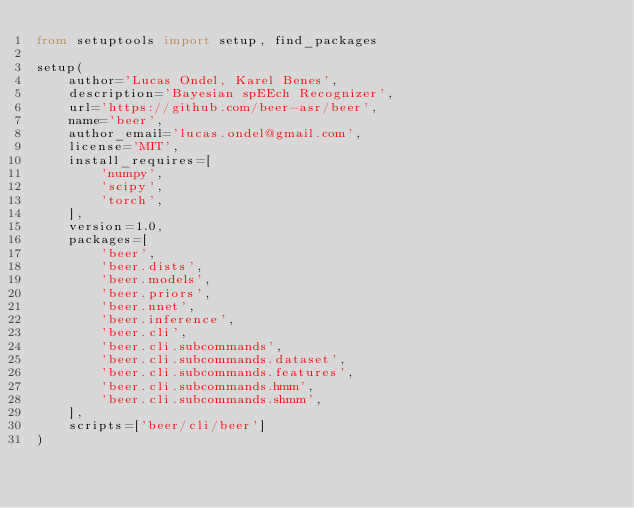<code> <loc_0><loc_0><loc_500><loc_500><_Python_>from setuptools import setup, find_packages

setup(
    author='Lucas Ondel, Karel Benes',
    description='Bayesian spEEch Recognizer',
    url='https://github.com/beer-asr/beer',
    name='beer',
    author_email='lucas.ondel@gmail.com',
    license='MIT',
    install_requires=[
        'numpy',
        'scipy',
        'torch',
    ],
    version=1.0,
    packages=[
        'beer',
        'beer.dists',
        'beer.models',
        'beer.priors',
        'beer.nnet',
        'beer.inference',
        'beer.cli',
        'beer.cli.subcommands',
        'beer.cli.subcommands.dataset',
        'beer.cli.subcommands.features',
        'beer.cli.subcommands.hmm',
        'beer.cli.subcommands.shmm',
    ],
    scripts=['beer/cli/beer']
)


</code> 